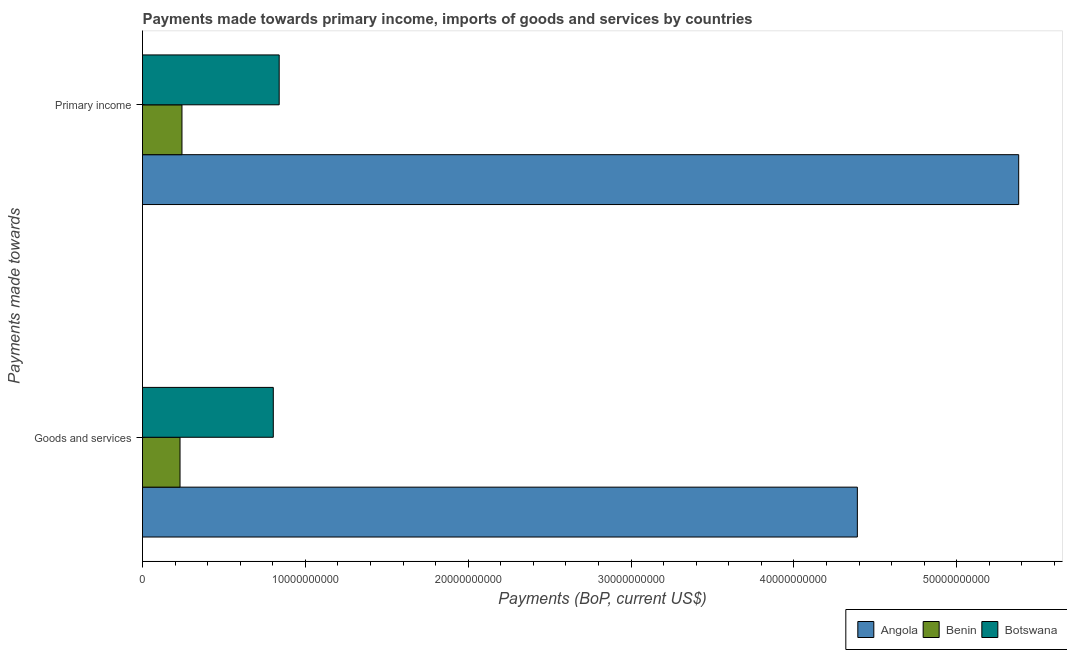How many different coloured bars are there?
Keep it short and to the point. 3. How many groups of bars are there?
Provide a succinct answer. 2. Are the number of bars on each tick of the Y-axis equal?
Provide a succinct answer. Yes. How many bars are there on the 1st tick from the top?
Keep it short and to the point. 3. How many bars are there on the 1st tick from the bottom?
Provide a succinct answer. 3. What is the label of the 1st group of bars from the top?
Your answer should be compact. Primary income. What is the payments made towards primary income in Benin?
Keep it short and to the point. 2.42e+09. Across all countries, what is the maximum payments made towards primary income?
Ensure brevity in your answer.  5.38e+1. Across all countries, what is the minimum payments made towards primary income?
Offer a terse response. 2.42e+09. In which country was the payments made towards goods and services maximum?
Provide a short and direct response. Angola. In which country was the payments made towards goods and services minimum?
Your answer should be compact. Benin. What is the total payments made towards primary income in the graph?
Ensure brevity in your answer.  6.46e+1. What is the difference between the payments made towards primary income in Botswana and that in Angola?
Offer a very short reply. -4.54e+1. What is the difference between the payments made towards goods and services in Benin and the payments made towards primary income in Angola?
Offer a very short reply. -5.15e+1. What is the average payments made towards goods and services per country?
Your response must be concise. 1.81e+1. What is the difference between the payments made towards primary income and payments made towards goods and services in Benin?
Your response must be concise. 1.19e+08. What is the ratio of the payments made towards primary income in Botswana to that in Angola?
Your answer should be compact. 0.16. In how many countries, is the payments made towards goods and services greater than the average payments made towards goods and services taken over all countries?
Ensure brevity in your answer.  1. What does the 2nd bar from the top in Goods and services represents?
Keep it short and to the point. Benin. What does the 1st bar from the bottom in Goods and services represents?
Provide a short and direct response. Angola. Are all the bars in the graph horizontal?
Offer a terse response. Yes. What is the difference between two consecutive major ticks on the X-axis?
Provide a short and direct response. 1.00e+1. Are the values on the major ticks of X-axis written in scientific E-notation?
Provide a succinct answer. No. Does the graph contain any zero values?
Provide a succinct answer. No. Does the graph contain grids?
Your answer should be compact. No. How many legend labels are there?
Your answer should be compact. 3. What is the title of the graph?
Offer a very short reply. Payments made towards primary income, imports of goods and services by countries. What is the label or title of the X-axis?
Provide a succinct answer. Payments (BoP, current US$). What is the label or title of the Y-axis?
Keep it short and to the point. Payments made towards. What is the Payments (BoP, current US$) in Angola in Goods and services?
Your answer should be compact. 4.39e+1. What is the Payments (BoP, current US$) in Benin in Goods and services?
Your answer should be compact. 2.30e+09. What is the Payments (BoP, current US$) in Botswana in Goods and services?
Your response must be concise. 8.03e+09. What is the Payments (BoP, current US$) of Angola in Primary income?
Make the answer very short. 5.38e+1. What is the Payments (BoP, current US$) in Benin in Primary income?
Give a very brief answer. 2.42e+09. What is the Payments (BoP, current US$) of Botswana in Primary income?
Give a very brief answer. 8.39e+09. Across all Payments made towards, what is the maximum Payments (BoP, current US$) in Angola?
Your answer should be compact. 5.38e+1. Across all Payments made towards, what is the maximum Payments (BoP, current US$) in Benin?
Keep it short and to the point. 2.42e+09. Across all Payments made towards, what is the maximum Payments (BoP, current US$) of Botswana?
Keep it short and to the point. 8.39e+09. Across all Payments made towards, what is the minimum Payments (BoP, current US$) in Angola?
Your answer should be compact. 4.39e+1. Across all Payments made towards, what is the minimum Payments (BoP, current US$) in Benin?
Ensure brevity in your answer.  2.30e+09. Across all Payments made towards, what is the minimum Payments (BoP, current US$) in Botswana?
Give a very brief answer. 8.03e+09. What is the total Payments (BoP, current US$) in Angola in the graph?
Your answer should be compact. 9.77e+1. What is the total Payments (BoP, current US$) in Benin in the graph?
Offer a very short reply. 4.73e+09. What is the total Payments (BoP, current US$) of Botswana in the graph?
Your answer should be compact. 1.64e+1. What is the difference between the Payments (BoP, current US$) in Angola in Goods and services and that in Primary income?
Your answer should be compact. -9.91e+09. What is the difference between the Payments (BoP, current US$) in Benin in Goods and services and that in Primary income?
Ensure brevity in your answer.  -1.19e+08. What is the difference between the Payments (BoP, current US$) in Botswana in Goods and services and that in Primary income?
Offer a very short reply. -3.62e+08. What is the difference between the Payments (BoP, current US$) of Angola in Goods and services and the Payments (BoP, current US$) of Benin in Primary income?
Make the answer very short. 4.15e+1. What is the difference between the Payments (BoP, current US$) in Angola in Goods and services and the Payments (BoP, current US$) in Botswana in Primary income?
Make the answer very short. 3.55e+1. What is the difference between the Payments (BoP, current US$) in Benin in Goods and services and the Payments (BoP, current US$) in Botswana in Primary income?
Provide a succinct answer. -6.09e+09. What is the average Payments (BoP, current US$) of Angola per Payments made towards?
Give a very brief answer. 4.89e+1. What is the average Payments (BoP, current US$) of Benin per Payments made towards?
Provide a succinct answer. 2.36e+09. What is the average Payments (BoP, current US$) in Botswana per Payments made towards?
Make the answer very short. 8.21e+09. What is the difference between the Payments (BoP, current US$) of Angola and Payments (BoP, current US$) of Benin in Goods and services?
Offer a very short reply. 4.16e+1. What is the difference between the Payments (BoP, current US$) of Angola and Payments (BoP, current US$) of Botswana in Goods and services?
Keep it short and to the point. 3.59e+1. What is the difference between the Payments (BoP, current US$) in Benin and Payments (BoP, current US$) in Botswana in Goods and services?
Offer a terse response. -5.73e+09. What is the difference between the Payments (BoP, current US$) of Angola and Payments (BoP, current US$) of Benin in Primary income?
Provide a succinct answer. 5.14e+1. What is the difference between the Payments (BoP, current US$) of Angola and Payments (BoP, current US$) of Botswana in Primary income?
Ensure brevity in your answer.  4.54e+1. What is the difference between the Payments (BoP, current US$) of Benin and Payments (BoP, current US$) of Botswana in Primary income?
Offer a very short reply. -5.97e+09. What is the ratio of the Payments (BoP, current US$) of Angola in Goods and services to that in Primary income?
Provide a succinct answer. 0.82. What is the ratio of the Payments (BoP, current US$) of Benin in Goods and services to that in Primary income?
Your answer should be compact. 0.95. What is the ratio of the Payments (BoP, current US$) in Botswana in Goods and services to that in Primary income?
Your answer should be very brief. 0.96. What is the difference between the highest and the second highest Payments (BoP, current US$) in Angola?
Give a very brief answer. 9.91e+09. What is the difference between the highest and the second highest Payments (BoP, current US$) in Benin?
Your answer should be very brief. 1.19e+08. What is the difference between the highest and the second highest Payments (BoP, current US$) of Botswana?
Provide a short and direct response. 3.62e+08. What is the difference between the highest and the lowest Payments (BoP, current US$) of Angola?
Provide a succinct answer. 9.91e+09. What is the difference between the highest and the lowest Payments (BoP, current US$) of Benin?
Offer a terse response. 1.19e+08. What is the difference between the highest and the lowest Payments (BoP, current US$) in Botswana?
Ensure brevity in your answer.  3.62e+08. 